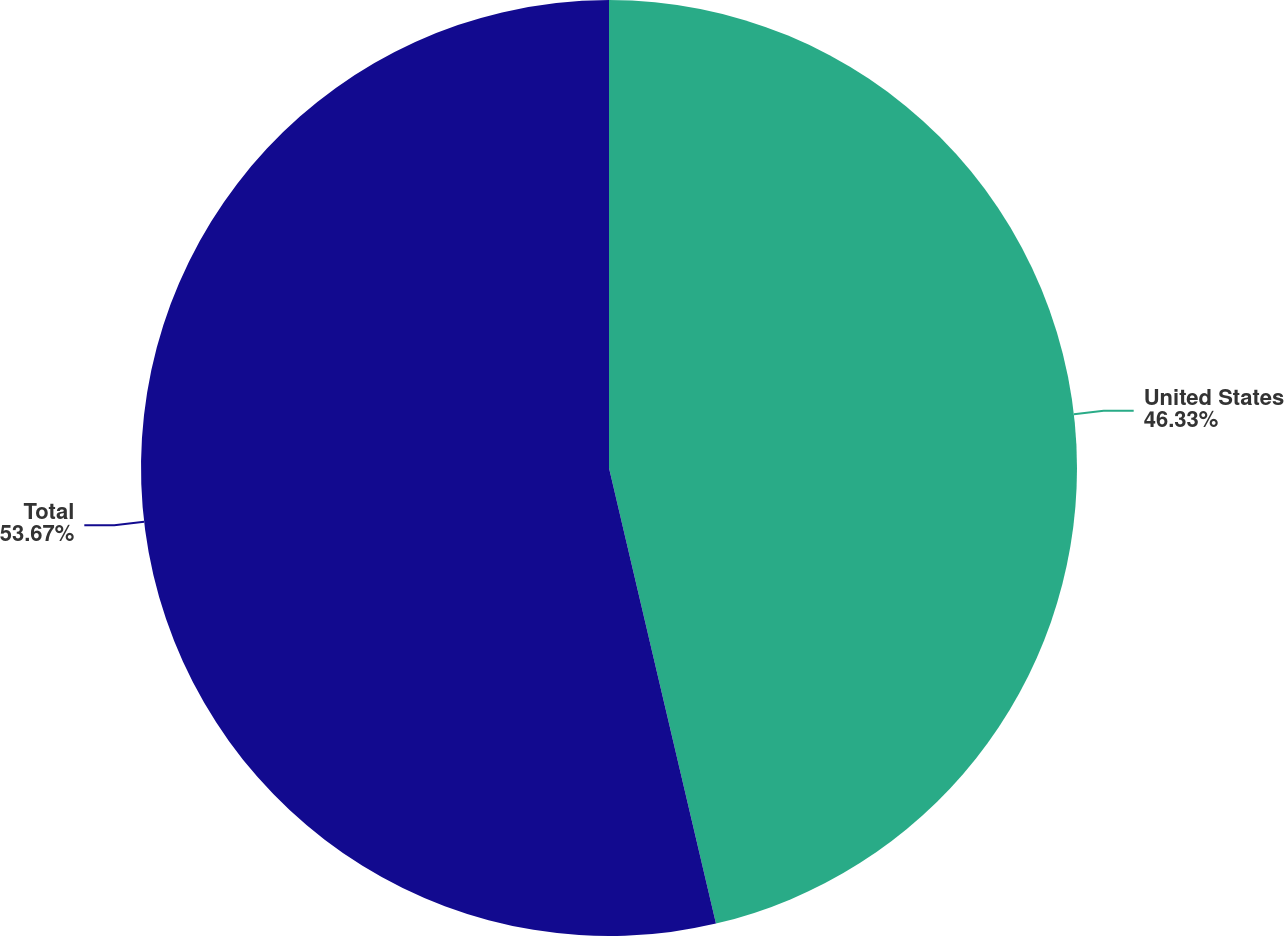<chart> <loc_0><loc_0><loc_500><loc_500><pie_chart><fcel>United States<fcel>Total<nl><fcel>46.33%<fcel>53.67%<nl></chart> 